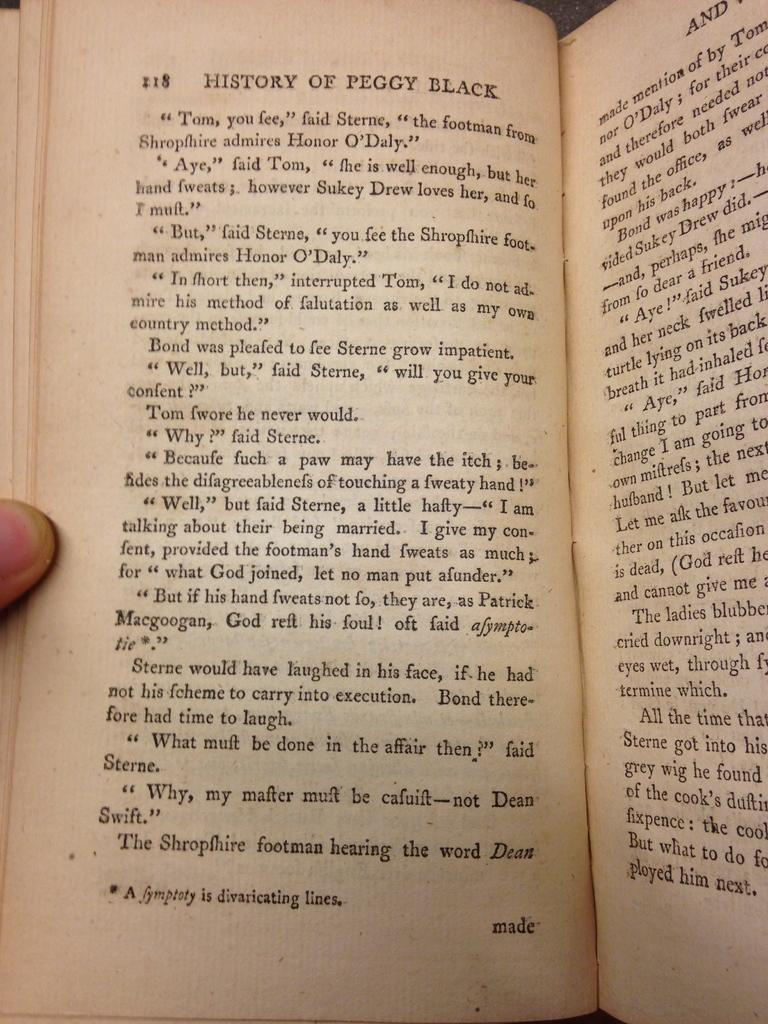What object is present in the image? There is a book in the image. What is a notable feature of the book? The book has pages. What can be found on the pages of the book? There is text on the pages. Can you describe the person's finger in the image? A person's finger is visible on the left side of the image. What time is displayed on the hour hand of the book in the image? There is no hour hand or clock present in the image; it features a book with pages and text. Can you describe the coastline visible in the image? There is no coastline present in the image; it features a book with pages and text. 